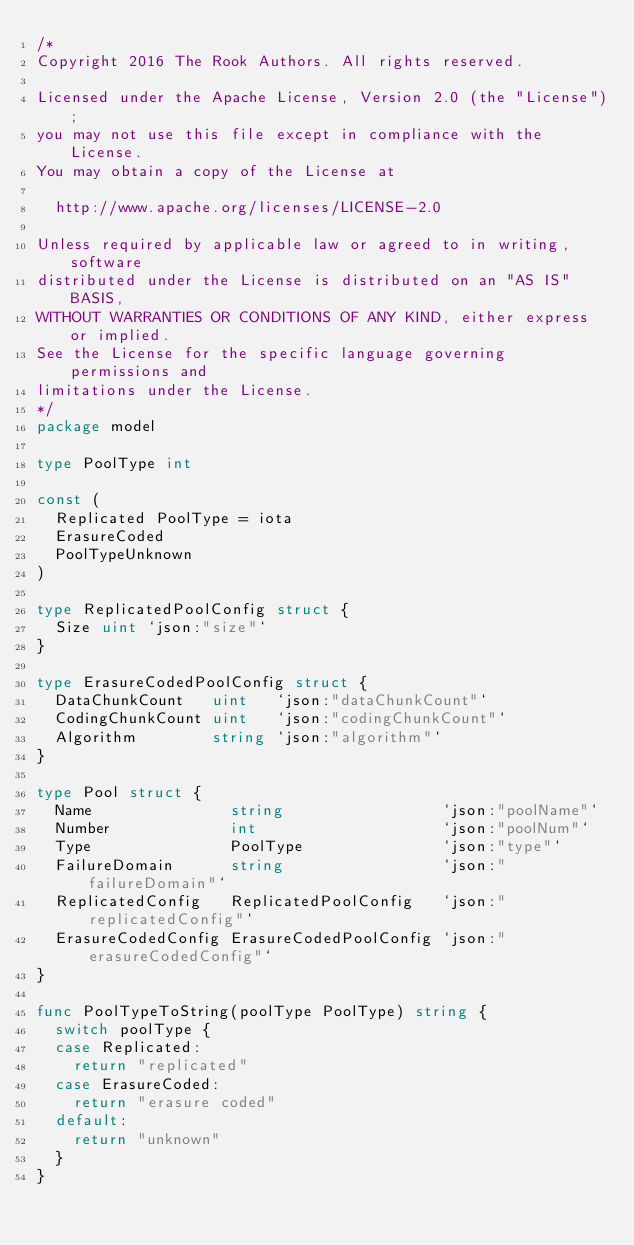<code> <loc_0><loc_0><loc_500><loc_500><_Go_>/*
Copyright 2016 The Rook Authors. All rights reserved.

Licensed under the Apache License, Version 2.0 (the "License");
you may not use this file except in compliance with the License.
You may obtain a copy of the License at

	http://www.apache.org/licenses/LICENSE-2.0

Unless required by applicable law or agreed to in writing, software
distributed under the License is distributed on an "AS IS" BASIS,
WITHOUT WARRANTIES OR CONDITIONS OF ANY KIND, either express or implied.
See the License for the specific language governing permissions and
limitations under the License.
*/
package model

type PoolType int

const (
	Replicated PoolType = iota
	ErasureCoded
	PoolTypeUnknown
)

type ReplicatedPoolConfig struct {
	Size uint `json:"size"`
}

type ErasureCodedPoolConfig struct {
	DataChunkCount   uint   `json:"dataChunkCount"`
	CodingChunkCount uint   `json:"codingChunkCount"`
	Algorithm        string `json:"algorithm"`
}

type Pool struct {
	Name               string                 `json:"poolName"`
	Number             int                    `json:"poolNum"`
	Type               PoolType               `json:"type"`
	FailureDomain      string                 `json:"failureDomain"`
	ReplicatedConfig   ReplicatedPoolConfig   `json:"replicatedConfig"`
	ErasureCodedConfig ErasureCodedPoolConfig `json:"erasureCodedConfig"`
}

func PoolTypeToString(poolType PoolType) string {
	switch poolType {
	case Replicated:
		return "replicated"
	case ErasureCoded:
		return "erasure coded"
	default:
		return "unknown"
	}
}
</code> 